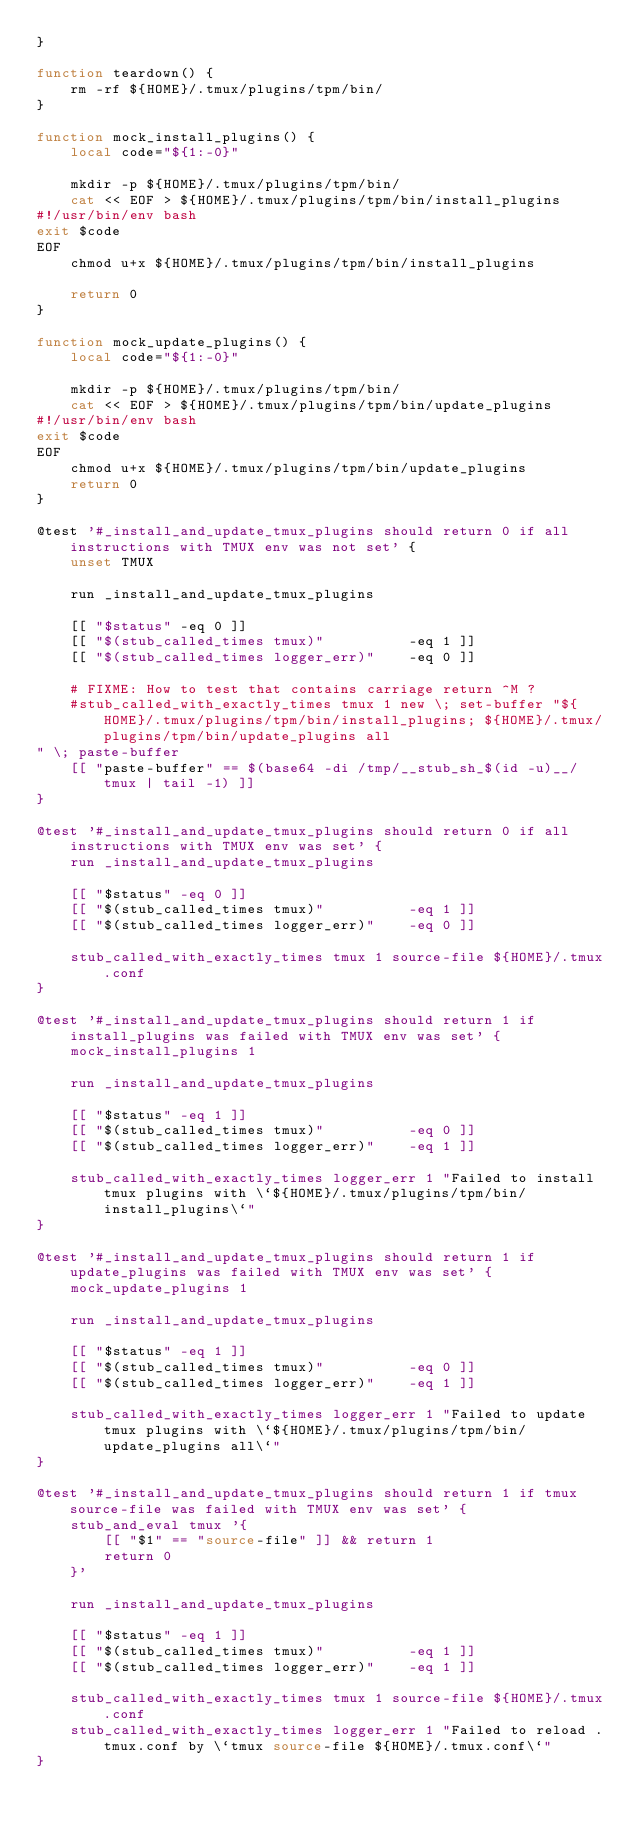<code> <loc_0><loc_0><loc_500><loc_500><_Bash_>}

function teardown() {
    rm -rf ${HOME}/.tmux/plugins/tpm/bin/
}

function mock_install_plugins() {
    local code="${1:-0}"

    mkdir -p ${HOME}/.tmux/plugins/tpm/bin/
    cat << EOF > ${HOME}/.tmux/plugins/tpm/bin/install_plugins
#!/usr/bin/env bash
exit $code
EOF
    chmod u+x ${HOME}/.tmux/plugins/tpm/bin/install_plugins

    return 0
}

function mock_update_plugins() {
    local code="${1:-0}"

    mkdir -p ${HOME}/.tmux/plugins/tpm/bin/
    cat << EOF > ${HOME}/.tmux/plugins/tpm/bin/update_plugins
#!/usr/bin/env bash
exit $code
EOF
    chmod u+x ${HOME}/.tmux/plugins/tpm/bin/update_plugins
    return 0
}

@test '#_install_and_update_tmux_plugins should return 0 if all instructions with TMUX env was not set' {
    unset TMUX

    run _install_and_update_tmux_plugins

    [[ "$status" -eq 0 ]]
    [[ "$(stub_called_times tmux)"          -eq 1 ]]
    [[ "$(stub_called_times logger_err)"    -eq 0 ]]

    # FIXME: How to test that contains carriage return ^M ?
    #stub_called_with_exactly_times tmux 1 new \; set-buffer "${HOME}/.tmux/plugins/tpm/bin/install_plugins; ${HOME}/.tmux/plugins/tpm/bin/update_plugins all" \; paste-buffer
    [[ "paste-buffer" == $(base64 -di /tmp/__stub_sh_$(id -u)__/tmux | tail -1) ]]
}

@test '#_install_and_update_tmux_plugins should return 0 if all instructions with TMUX env was set' {
    run _install_and_update_tmux_plugins

    [[ "$status" -eq 0 ]]
    [[ "$(stub_called_times tmux)"          -eq 1 ]]
    [[ "$(stub_called_times logger_err)"    -eq 0 ]]

    stub_called_with_exactly_times tmux 1 source-file ${HOME}/.tmux.conf
}

@test '#_install_and_update_tmux_plugins should return 1 if install_plugins was failed with TMUX env was set' {
    mock_install_plugins 1

    run _install_and_update_tmux_plugins

    [[ "$status" -eq 1 ]]
    [[ "$(stub_called_times tmux)"          -eq 0 ]]
    [[ "$(stub_called_times logger_err)"    -eq 1 ]]

    stub_called_with_exactly_times logger_err 1 "Failed to install tmux plugins with \`${HOME}/.tmux/plugins/tpm/bin/install_plugins\`"
}

@test '#_install_and_update_tmux_plugins should return 1 if update_plugins was failed with TMUX env was set' {
    mock_update_plugins 1

    run _install_and_update_tmux_plugins

    [[ "$status" -eq 1 ]]
    [[ "$(stub_called_times tmux)"          -eq 0 ]]
    [[ "$(stub_called_times logger_err)"    -eq 1 ]]

    stub_called_with_exactly_times logger_err 1 "Failed to update tmux plugins with \`${HOME}/.tmux/plugins/tpm/bin/update_plugins all\`"
}

@test '#_install_and_update_tmux_plugins should return 1 if tmux source-file was failed with TMUX env was set' {
    stub_and_eval tmux '{
        [[ "$1" == "source-file" ]] && return 1
        return 0
    }'

    run _install_and_update_tmux_plugins

    [[ "$status" -eq 1 ]]
    [[ "$(stub_called_times tmux)"          -eq 1 ]]
    [[ "$(stub_called_times logger_err)"    -eq 1 ]]

    stub_called_with_exactly_times tmux 1 source-file ${HOME}/.tmux.conf
    stub_called_with_exactly_times logger_err 1 "Failed to reload .tmux.conf by \`tmux source-file ${HOME}/.tmux.conf\`"
}

</code> 